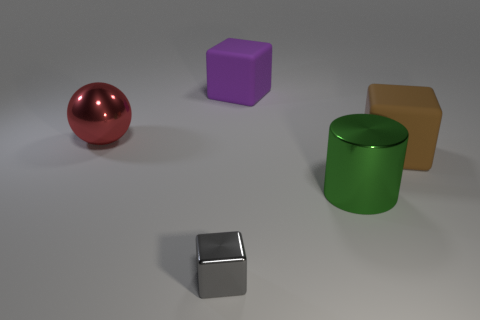Subtract all red blocks. Subtract all cyan spheres. How many blocks are left? 3 Add 5 cylinders. How many objects exist? 10 Subtract all cubes. How many objects are left? 2 Add 4 metallic balls. How many metallic balls exist? 5 Subtract 1 red balls. How many objects are left? 4 Subtract all small gray cylinders. Subtract all green metal things. How many objects are left? 4 Add 2 shiny objects. How many shiny objects are left? 5 